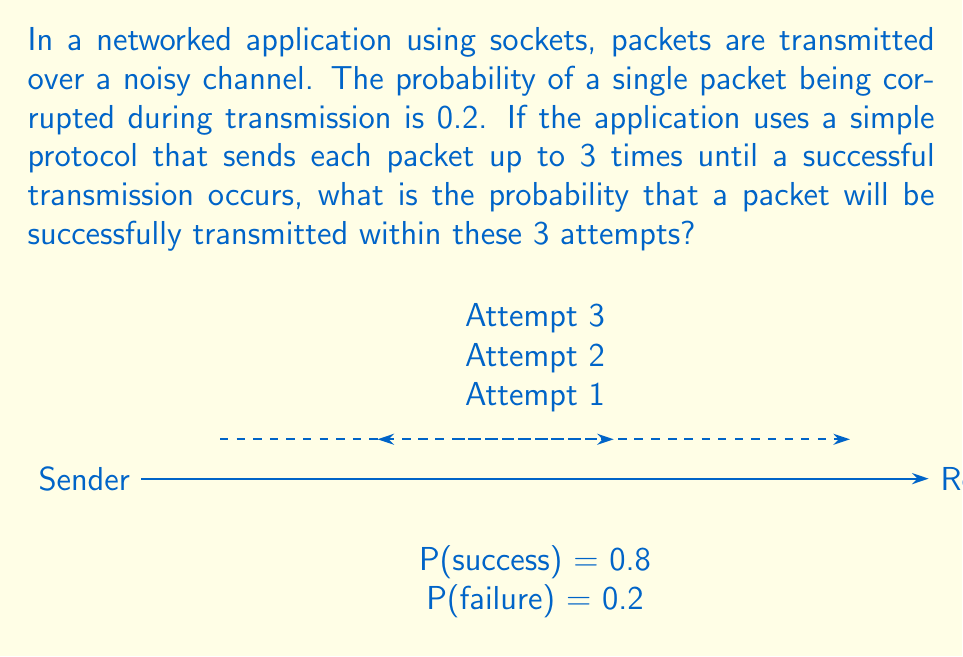Can you solve this math problem? Let's approach this step-by-step:

1) First, let's define our events:
   - S: Successful transmission
   - F: Failed transmission

2) We know that P(F) = 0.2, so P(S) = 1 - P(F) = 0.8

3) Now, we need to calculate the probability of success within 3 attempts. This can happen in three ways:
   - Success on the 1st attempt
   - Failure on 1st, success on 2nd
   - Failure on 1st and 2nd, success on 3rd

4) Let's calculate each probability:
   - P(S on 1st) = 0.8
   - P(F on 1st, S on 2nd) = 0.2 * 0.8
   - P(F on 1st, F on 2nd, S on 3rd) = 0.2 * 0.2 * 0.8

5) The total probability is the sum of these mutually exclusive events:

   $$P(\text{success within 3 attempts}) = 0.8 + (0.2 * 0.8) + (0.2^2 * 0.8)$$

6) Let's simplify:
   $$= 0.8 + 0.16 + 0.032$$
   $$= 0.992$$

Therefore, the probability of successful transmission within 3 attempts is 0.992 or 99.2%.
Answer: 0.992 